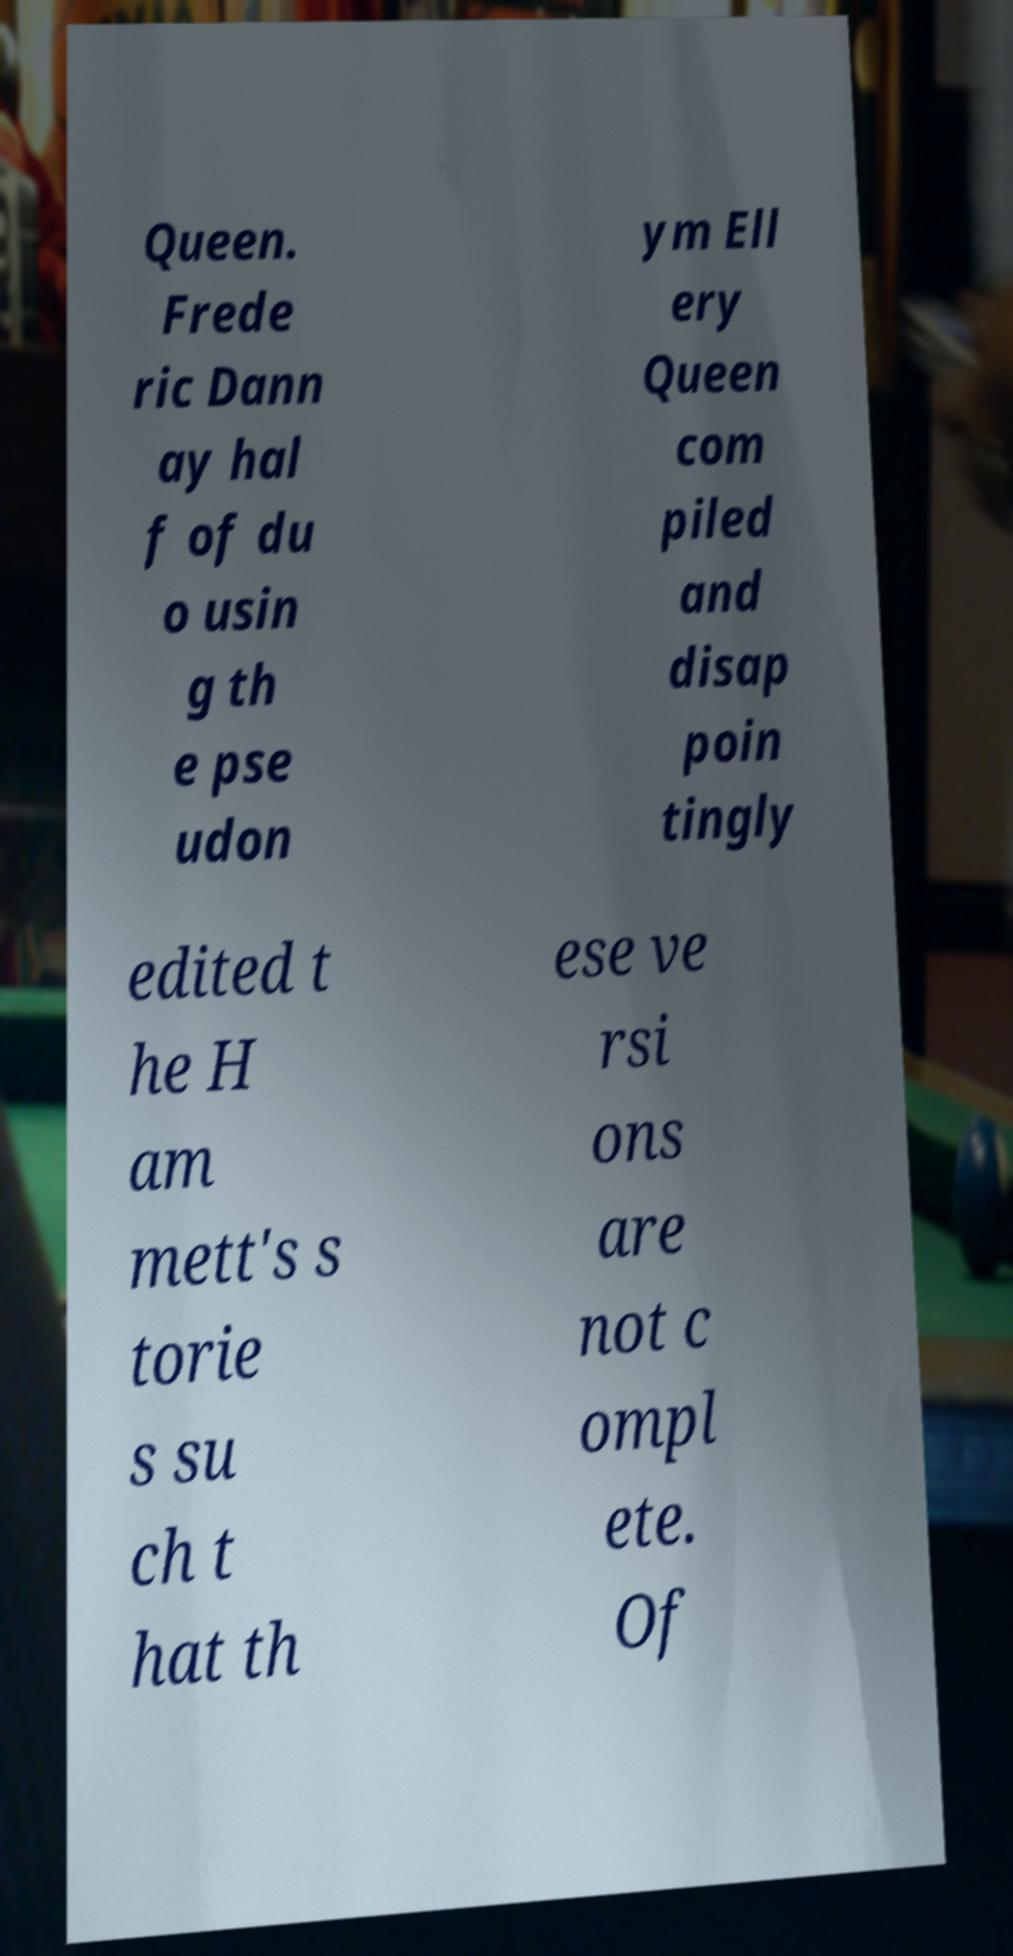Can you accurately transcribe the text from the provided image for me? Queen. Frede ric Dann ay hal f of du o usin g th e pse udon ym Ell ery Queen com piled and disap poin tingly edited t he H am mett's s torie s su ch t hat th ese ve rsi ons are not c ompl ete. Of 